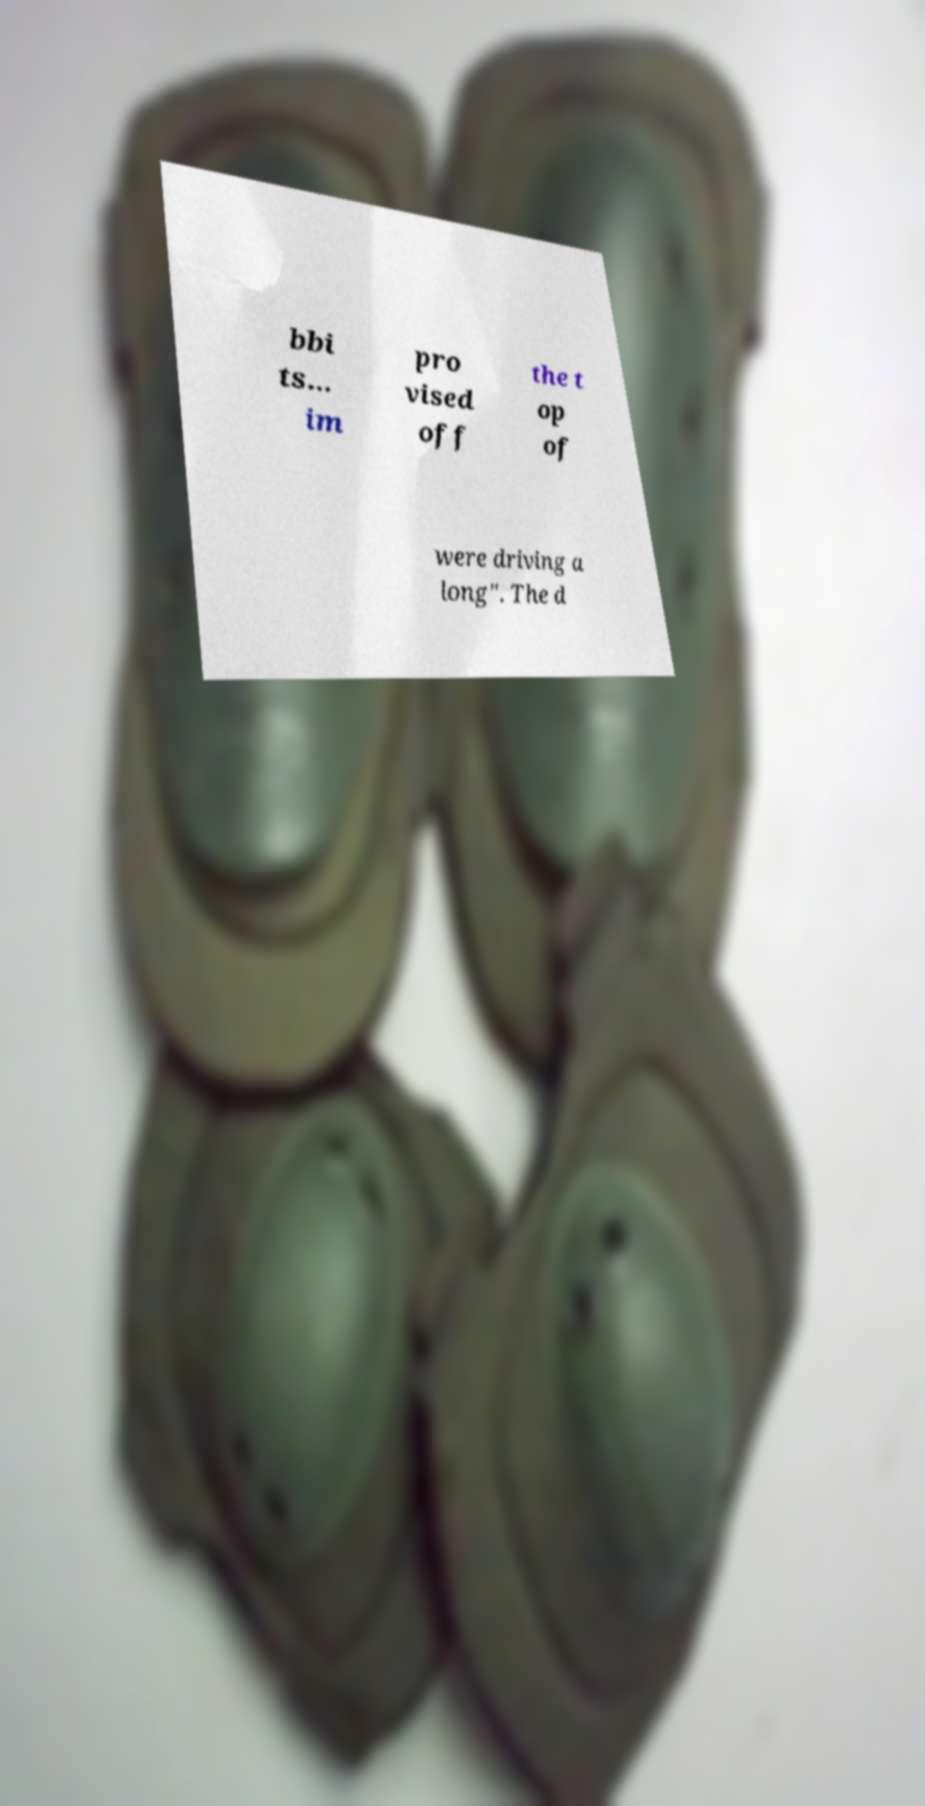What messages or text are displayed in this image? I need them in a readable, typed format. bbi ts... im pro vised off the t op of were driving a long". The d 